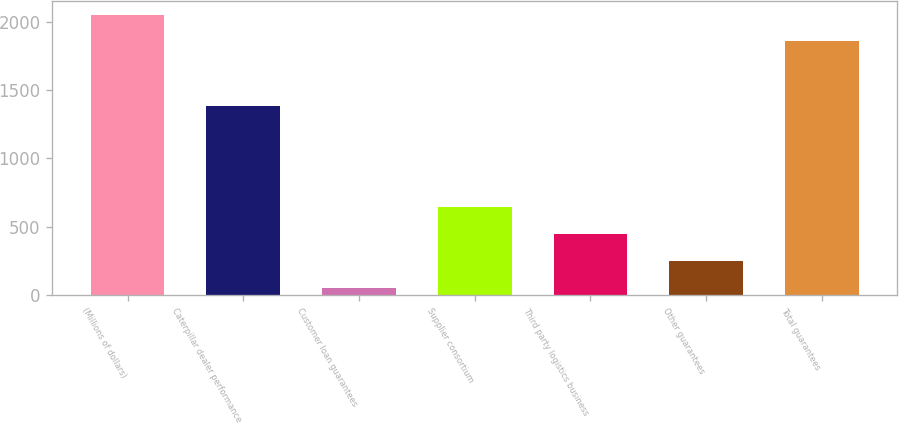Convert chart to OTSL. <chart><loc_0><loc_0><loc_500><loc_500><bar_chart><fcel>(Millions of dollars)<fcel>Caterpillar dealer performance<fcel>Customer loan guarantees<fcel>Supplier consortium<fcel>Third party logistics business<fcel>Other guarantees<fcel>Total guarantees<nl><fcel>2052.5<fcel>1384<fcel>51<fcel>640.5<fcel>444<fcel>247.5<fcel>1856<nl></chart> 